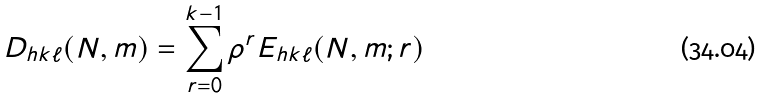<formula> <loc_0><loc_0><loc_500><loc_500>D _ { h k \ell } ( N , m ) = \sum _ { r = 0 } ^ { k - 1 } \rho ^ { r } E _ { h k \ell } ( N , m ; r )</formula> 